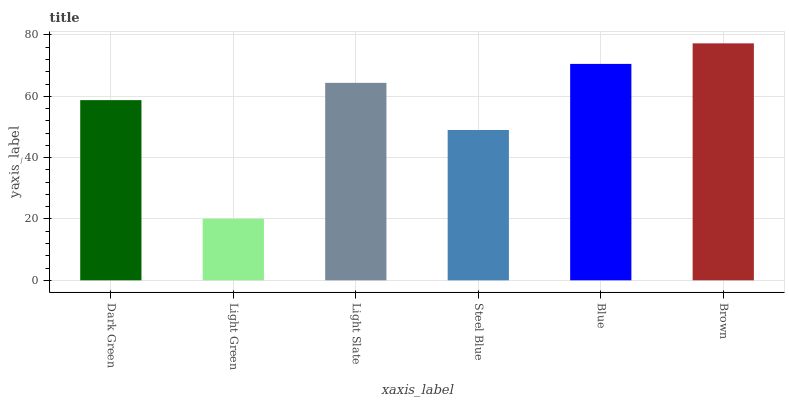Is Light Slate the minimum?
Answer yes or no. No. Is Light Slate the maximum?
Answer yes or no. No. Is Light Slate greater than Light Green?
Answer yes or no. Yes. Is Light Green less than Light Slate?
Answer yes or no. Yes. Is Light Green greater than Light Slate?
Answer yes or no. No. Is Light Slate less than Light Green?
Answer yes or no. No. Is Light Slate the high median?
Answer yes or no. Yes. Is Dark Green the low median?
Answer yes or no. Yes. Is Blue the high median?
Answer yes or no. No. Is Brown the low median?
Answer yes or no. No. 